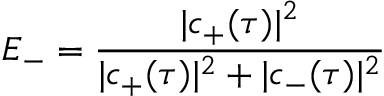<formula> <loc_0><loc_0><loc_500><loc_500>E _ { - } = \frac { | c _ { + } ( \tau ) | ^ { 2 } } { | c _ { + } ( \tau ) | ^ { 2 } + | c _ { - } ( \tau ) | ^ { 2 } }</formula> 